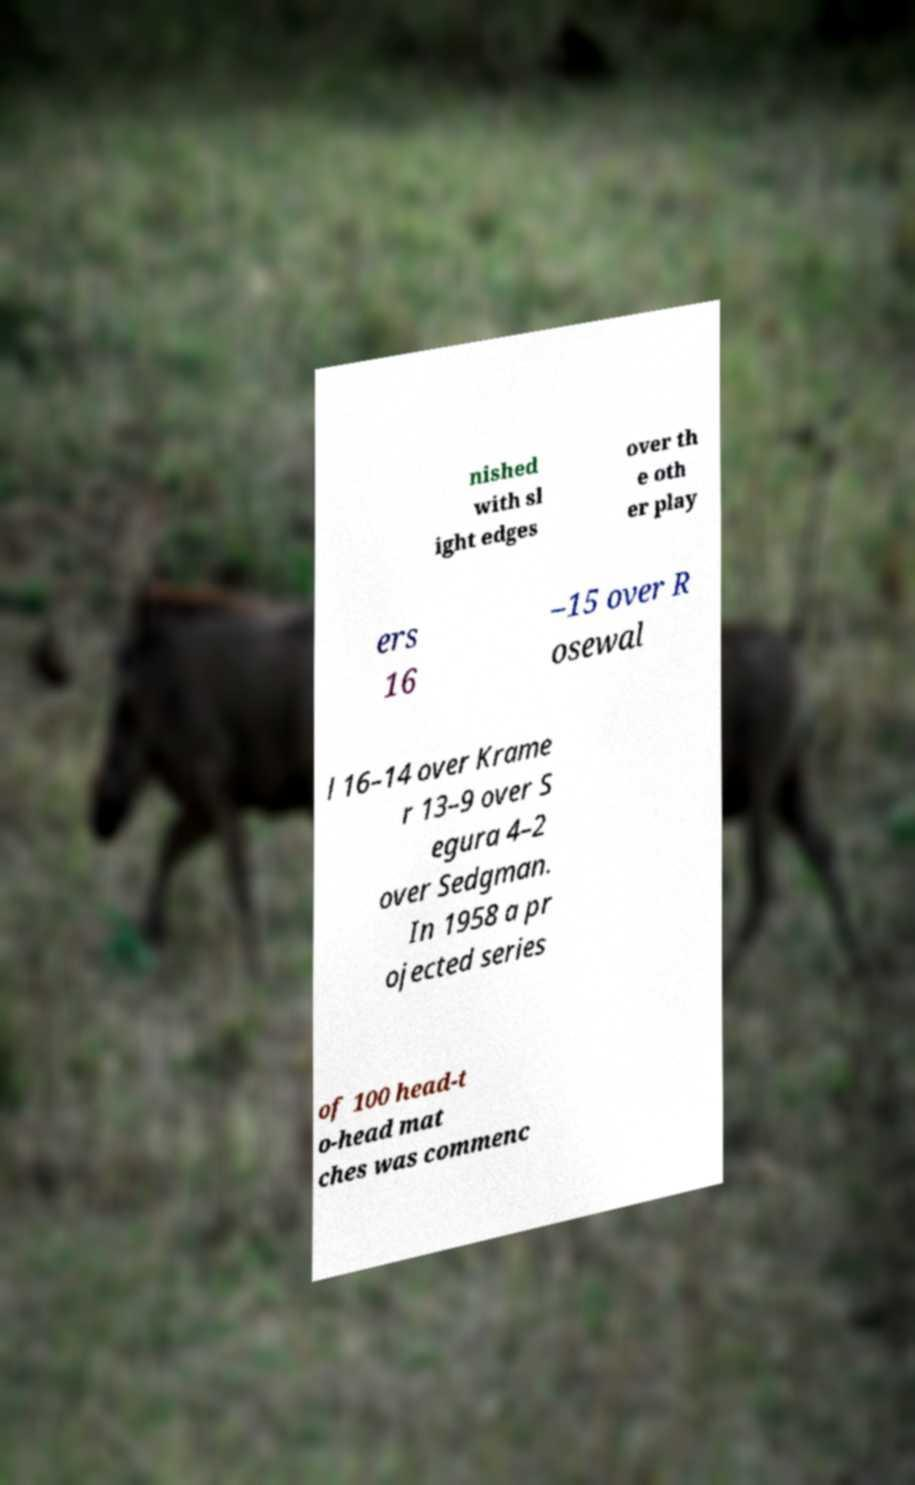For documentation purposes, I need the text within this image transcribed. Could you provide that? nished with sl ight edges over th e oth er play ers 16 –15 over R osewal l 16–14 over Krame r 13–9 over S egura 4–2 over Sedgman. In 1958 a pr ojected series of 100 head-t o-head mat ches was commenc 